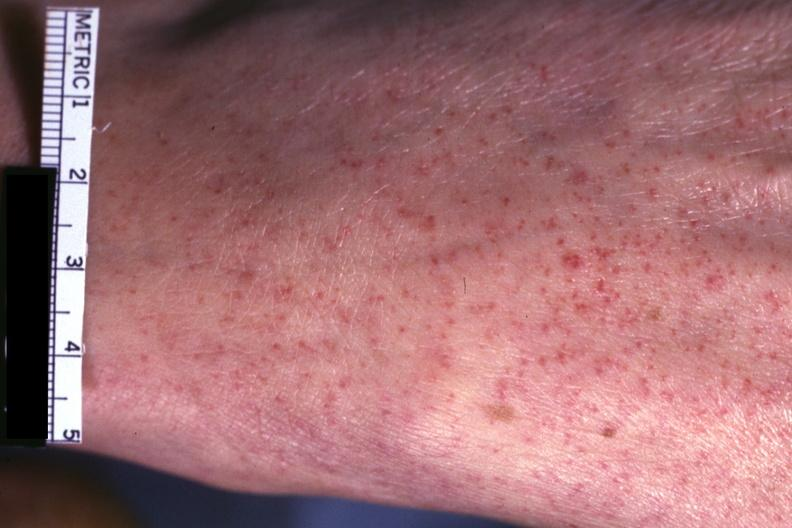does excellent example show good close-up of lesions?
Answer the question using a single word or phrase. No 